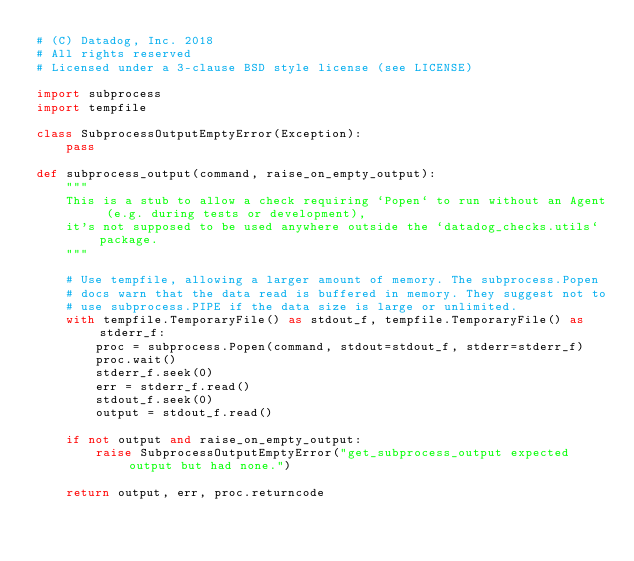Convert code to text. <code><loc_0><loc_0><loc_500><loc_500><_Python_># (C) Datadog, Inc. 2018
# All rights reserved
# Licensed under a 3-clause BSD style license (see LICENSE)

import subprocess
import tempfile

class SubprocessOutputEmptyError(Exception):
    pass

def subprocess_output(command, raise_on_empty_output):
    """
    This is a stub to allow a check requiring `Popen` to run without an Agent (e.g. during tests or development),
    it's not supposed to be used anywhere outside the `datadog_checks.utils` package.
    """

    # Use tempfile, allowing a larger amount of memory. The subprocess.Popen
    # docs warn that the data read is buffered in memory. They suggest not to
    # use subprocess.PIPE if the data size is large or unlimited.
    with tempfile.TemporaryFile() as stdout_f, tempfile.TemporaryFile() as stderr_f:
        proc = subprocess.Popen(command, stdout=stdout_f, stderr=stderr_f)
        proc.wait()
        stderr_f.seek(0)
        err = stderr_f.read()
        stdout_f.seek(0)
        output = stdout_f.read()

    if not output and raise_on_empty_output:
        raise SubprocessOutputEmptyError("get_subprocess_output expected output but had none.")

    return output, err, proc.returncode
</code> 